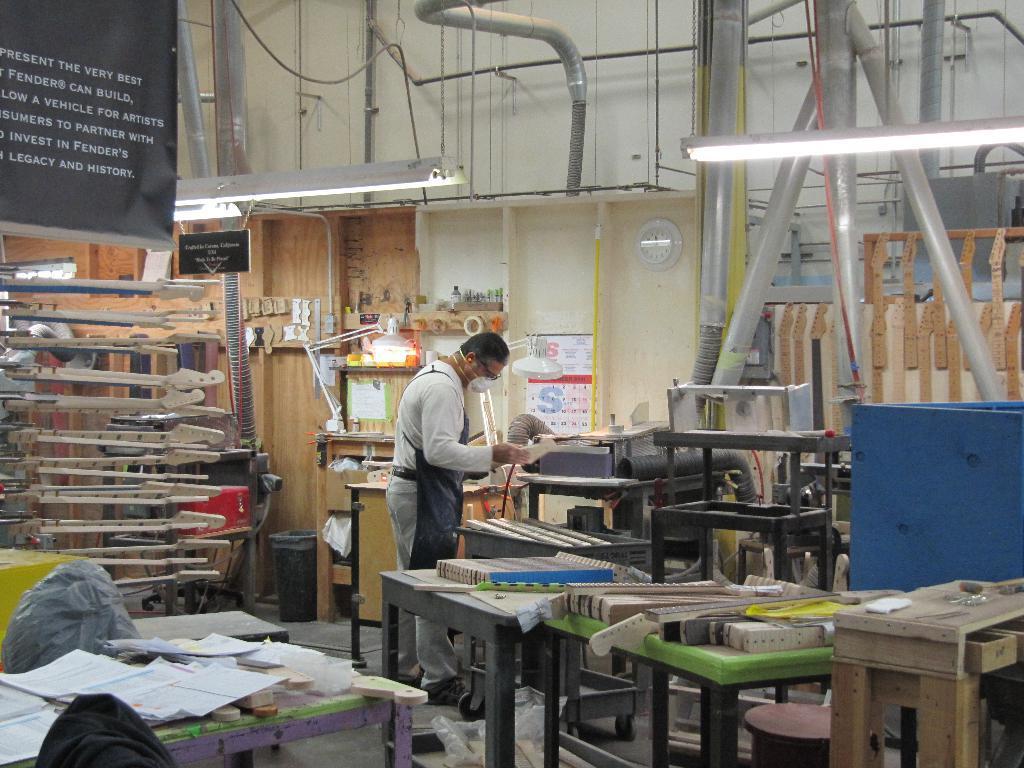Could you give a brief overview of what you see in this image? In this image there is a man standing. He is wearing an apron and a mask. He is holding an object. There are many tables in the image. There are objects on the tables. In the bottom left there is a table. On that table there are many papers. In the top left there is a banner. There is text on the banner. In the background there is a wall. There are pipes on the wall. There are lights hanging to the ceiling. There is a dustbin in the image. 